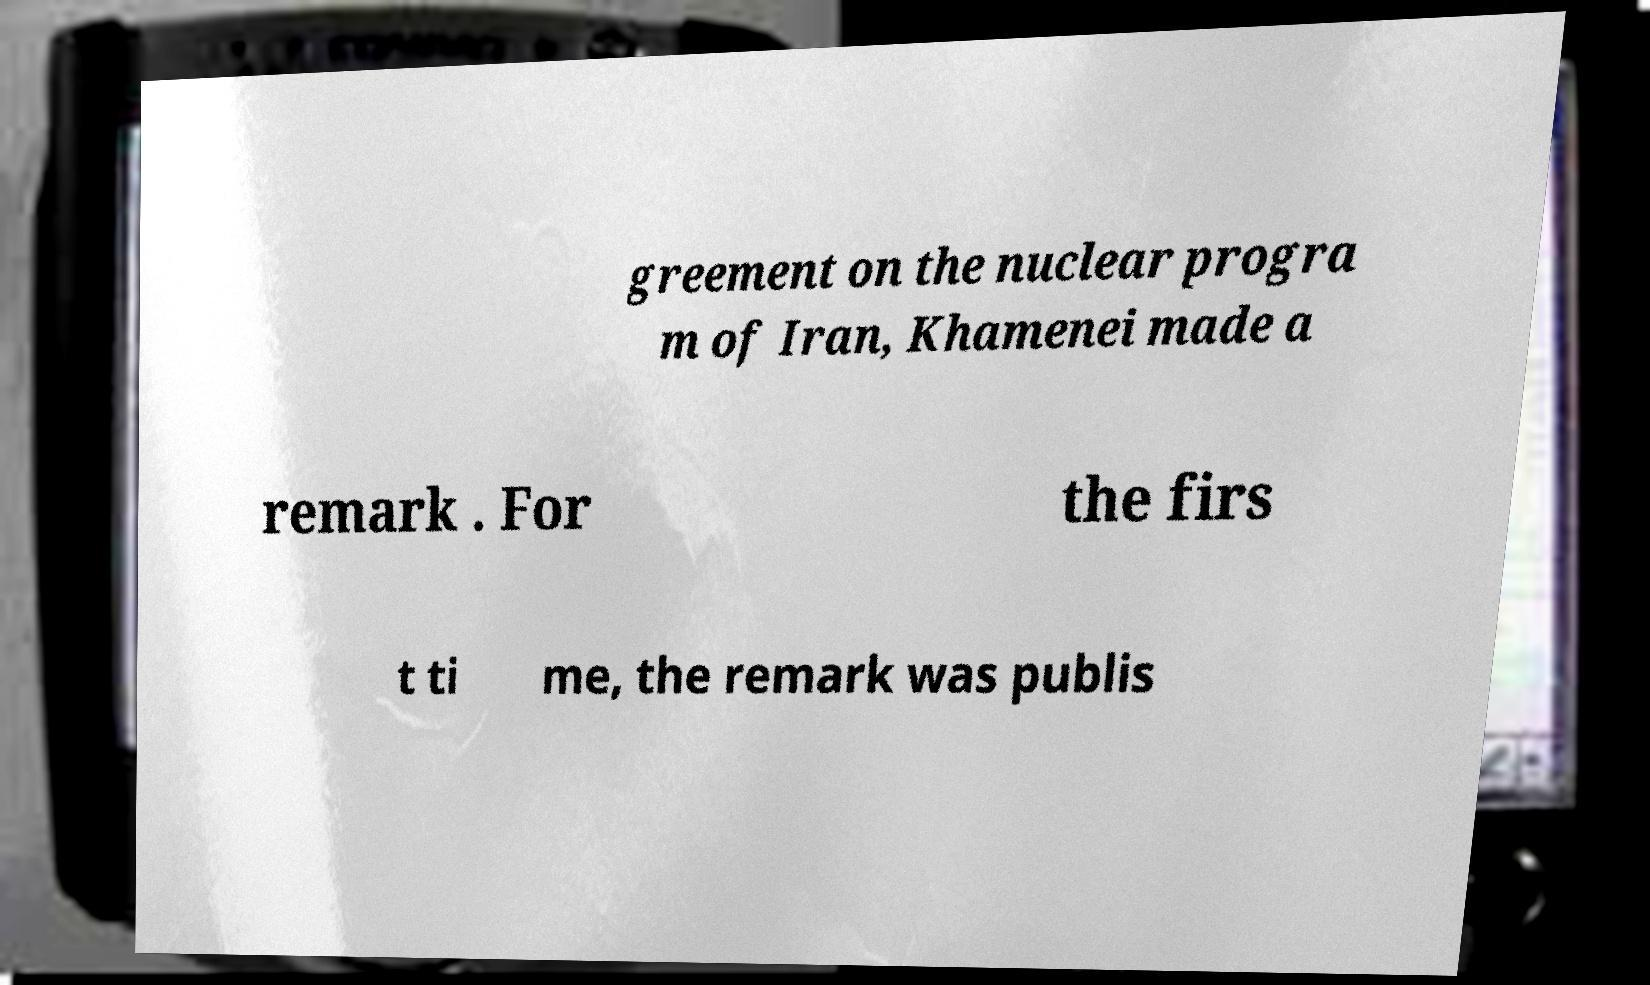For documentation purposes, I need the text within this image transcribed. Could you provide that? greement on the nuclear progra m of Iran, Khamenei made a remark . For the firs t ti me, the remark was publis 